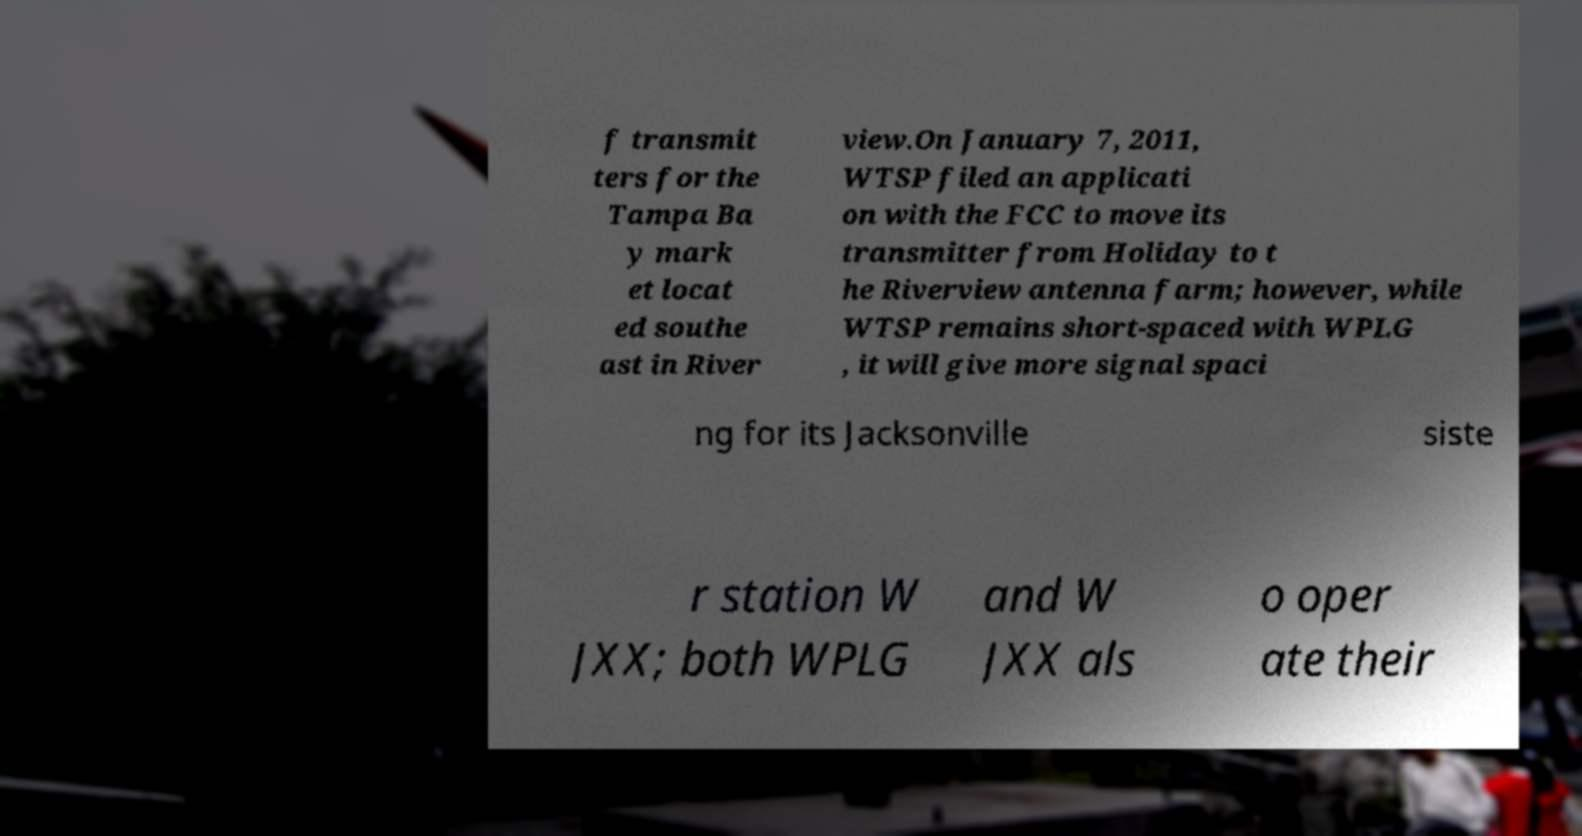Can you accurately transcribe the text from the provided image for me? f transmit ters for the Tampa Ba y mark et locat ed southe ast in River view.On January 7, 2011, WTSP filed an applicati on with the FCC to move its transmitter from Holiday to t he Riverview antenna farm; however, while WTSP remains short-spaced with WPLG , it will give more signal spaci ng for its Jacksonville siste r station W JXX; both WPLG and W JXX als o oper ate their 